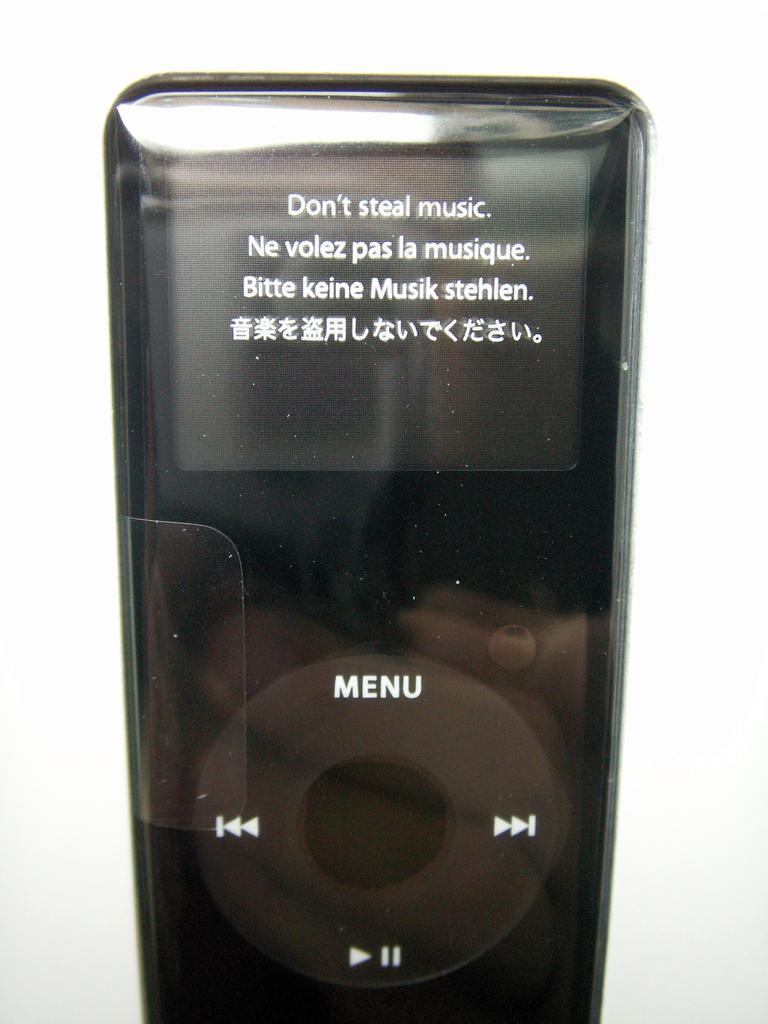What does the first line say at the top?
Provide a succinct answer. Don't steal music. 